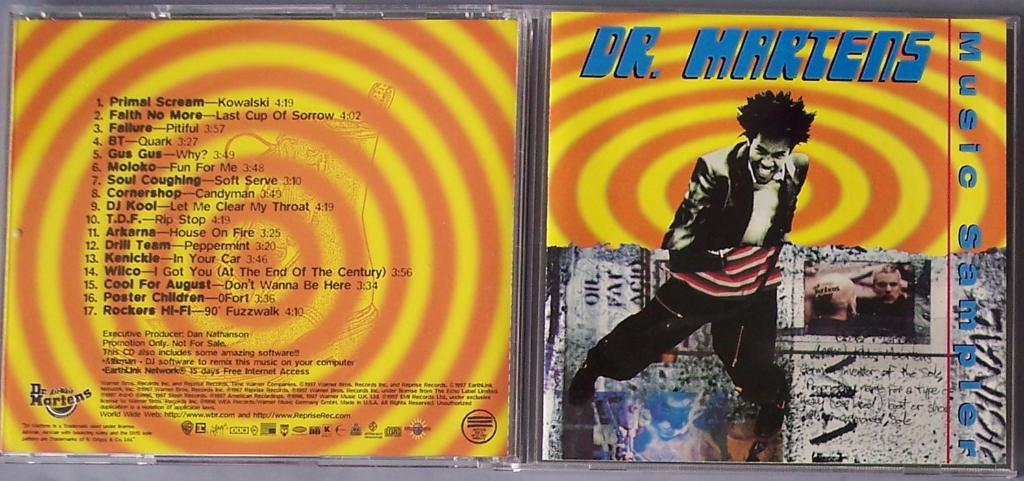<image>
Summarize the visual content of the image. the front and back covers of a case of dr martens musical album. 